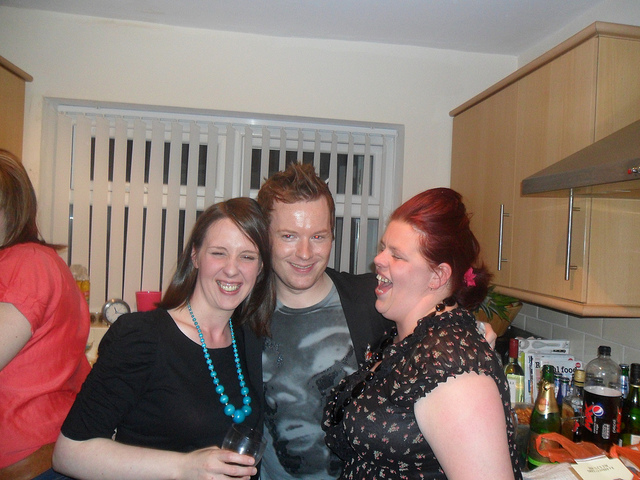<image>What pattern appears on the ceiling? There is no pattern appearing on the ceiling. It seems to be plain white. What pattern appears on the ceiling? I am not sure what pattern appears on the ceiling. It can be seen as 'none', 'solid', 'plain white', or 'plain'. 